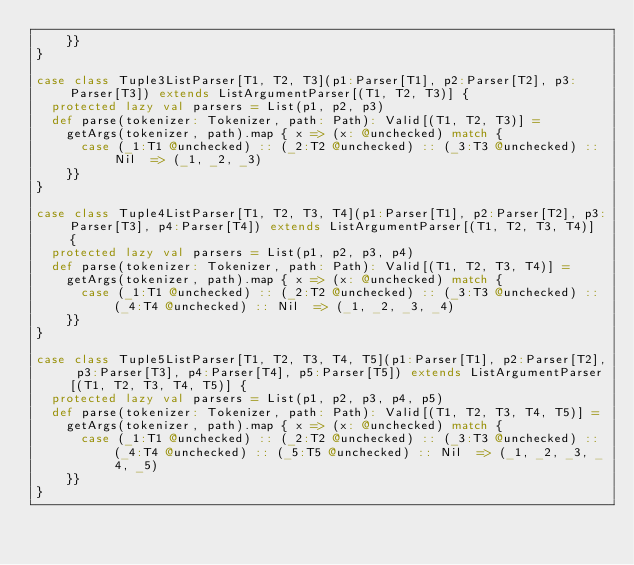<code> <loc_0><loc_0><loc_500><loc_500><_Scala_>    }}
}

case class Tuple3ListParser[T1, T2, T3](p1:Parser[T1], p2:Parser[T2], p3:Parser[T3]) extends ListArgumentParser[(T1, T2, T3)] {
  protected lazy val parsers = List(p1, p2, p3)
  def parse(tokenizer: Tokenizer, path: Path): Valid[(T1, T2, T3)] =
    getArgs(tokenizer, path).map { x => (x: @unchecked) match {
      case (_1:T1 @unchecked) :: (_2:T2 @unchecked) :: (_3:T3 @unchecked) :: Nil  => (_1, _2, _3)
    }}
}

case class Tuple4ListParser[T1, T2, T3, T4](p1:Parser[T1], p2:Parser[T2], p3:Parser[T3], p4:Parser[T4]) extends ListArgumentParser[(T1, T2, T3, T4)] {
  protected lazy val parsers = List(p1, p2, p3, p4)
  def parse(tokenizer: Tokenizer, path: Path): Valid[(T1, T2, T3, T4)] =
    getArgs(tokenizer, path).map { x => (x: @unchecked) match {
      case (_1:T1 @unchecked) :: (_2:T2 @unchecked) :: (_3:T3 @unchecked) :: (_4:T4 @unchecked) :: Nil  => (_1, _2, _3, _4)
    }}
}

case class Tuple5ListParser[T1, T2, T3, T4, T5](p1:Parser[T1], p2:Parser[T2], p3:Parser[T3], p4:Parser[T4], p5:Parser[T5]) extends ListArgumentParser[(T1, T2, T3, T4, T5)] {
  protected lazy val parsers = List(p1, p2, p3, p4, p5)
  def parse(tokenizer: Tokenizer, path: Path): Valid[(T1, T2, T3, T4, T5)] =
    getArgs(tokenizer, path).map { x => (x: @unchecked) match {
      case (_1:T1 @unchecked) :: (_2:T2 @unchecked) :: (_3:T3 @unchecked) :: (_4:T4 @unchecked) :: (_5:T5 @unchecked) :: Nil  => (_1, _2, _3, _4, _5)
    }}
}

</code> 